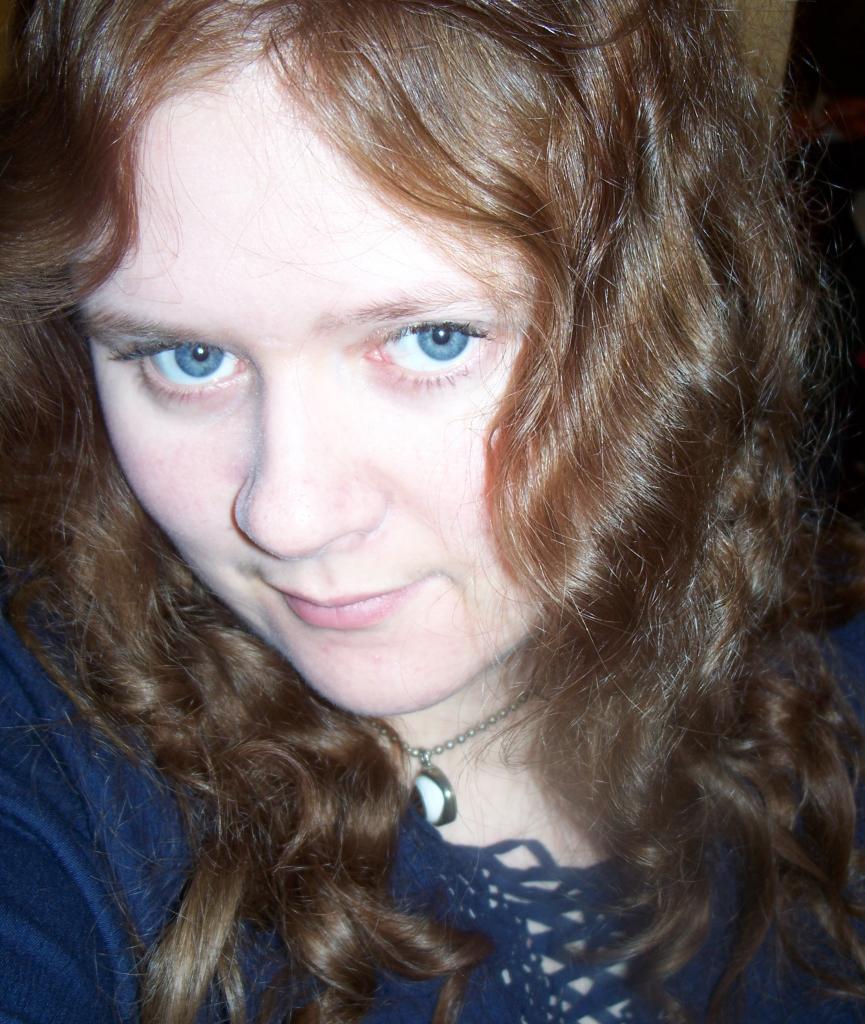Describe this image in one or two sentences. In the image we can see a woman. She is smiling. 